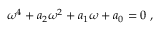Convert formula to latex. <formula><loc_0><loc_0><loc_500><loc_500>{ \omega } ^ { 4 } + a _ { 2 } { \omega } ^ { 2 } + a _ { 1 } { \omega } + a _ { 0 } = 0 \, ,</formula> 